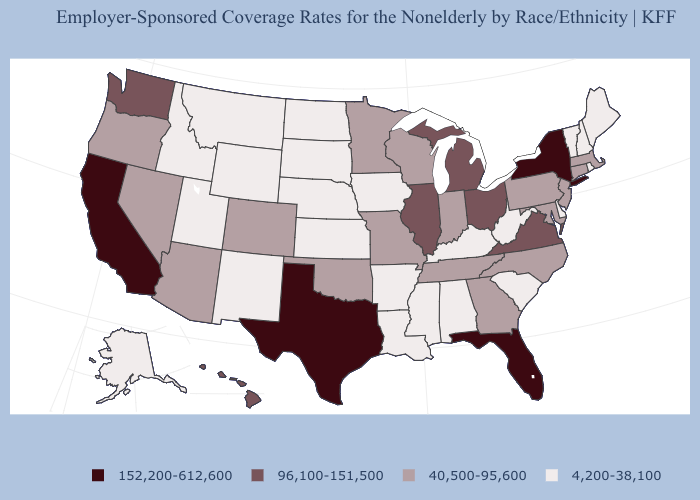What is the value of New Mexico?
Write a very short answer. 4,200-38,100. Name the states that have a value in the range 40,500-95,600?
Keep it brief. Arizona, Colorado, Connecticut, Georgia, Indiana, Maryland, Massachusetts, Minnesota, Missouri, Nevada, New Jersey, North Carolina, Oklahoma, Oregon, Pennsylvania, Tennessee, Wisconsin. Name the states that have a value in the range 40,500-95,600?
Concise answer only. Arizona, Colorado, Connecticut, Georgia, Indiana, Maryland, Massachusetts, Minnesota, Missouri, Nevada, New Jersey, North Carolina, Oklahoma, Oregon, Pennsylvania, Tennessee, Wisconsin. Name the states that have a value in the range 40,500-95,600?
Keep it brief. Arizona, Colorado, Connecticut, Georgia, Indiana, Maryland, Massachusetts, Minnesota, Missouri, Nevada, New Jersey, North Carolina, Oklahoma, Oregon, Pennsylvania, Tennessee, Wisconsin. What is the highest value in the South ?
Write a very short answer. 152,200-612,600. Name the states that have a value in the range 152,200-612,600?
Give a very brief answer. California, Florida, New York, Texas. What is the value of Louisiana?
Short answer required. 4,200-38,100. Does Oregon have a higher value than South Dakota?
Quick response, please. Yes. Name the states that have a value in the range 96,100-151,500?
Give a very brief answer. Hawaii, Illinois, Michigan, Ohio, Virginia, Washington. Does Texas have the highest value in the South?
Answer briefly. Yes. Which states hav the highest value in the MidWest?
Concise answer only. Illinois, Michigan, Ohio. Does Massachusetts have a lower value than Mississippi?
Write a very short answer. No. Which states have the highest value in the USA?
Write a very short answer. California, Florida, New York, Texas. What is the highest value in the USA?
Short answer required. 152,200-612,600. Among the states that border North Dakota , which have the lowest value?
Concise answer only. Montana, South Dakota. 